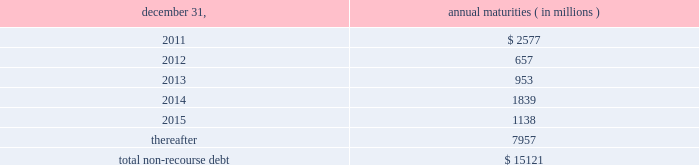The aes corporation notes to consolidated financial statements 2014 ( continued ) december 31 , 2010 , 2009 , and 2008 ( 3 ) multilateral loans include loans funded and guaranteed by bilaterals , multilaterals , development banks and other similar institutions .
( 4 ) non-recourse debt of $ 708 million as of december 31 , 2009 was excluded from non-recourse debt and included in current and long-term liabilities of held for sale and discontinued businesses in the accompanying consolidated balance sheets .
Non-recourse debt as of december 31 , 2010 is scheduled to reach maturity as set forth in the table below : december 31 , annual maturities ( in millions ) .
As of december 31 , 2010 , aes subsidiaries with facilities under construction had a total of approximately $ 432 million of committed but unused credit facilities available to fund construction and other related costs .
Excluding these facilities under construction , aes subsidiaries had approximately $ 893 million in a number of available but unused committed revolving credit lines to support their working capital , debt service reserves and other business needs .
These credit lines can be used in one or more of the following ways : solely for borrowings ; solely for letters of credit ; or a combination of these uses .
The weighted average interest rate on borrowings from these facilities was 3.24% ( 3.24 % ) at december 31 , 2010 .
Non-recourse debt covenants , restrictions and defaults the terms of the company 2019s non-recourse debt include certain financial and non-financial covenants .
These covenants are limited to subsidiary activity and vary among the subsidiaries .
These covenants may include but are not limited to maintenance of certain reserves , minimum levels of working capital and limitations on incurring additional indebtedness .
Compliance with certain covenants may not be objectively determinable .
As of december 31 , 2010 and 2009 , approximately $ 803 million and $ 653 million , respectively , of restricted cash was maintained in accordance with certain covenants of the non-recourse debt agreements , and these amounts were included within 201crestricted cash 201d and 201cdebt service reserves and other deposits 201d in the accompanying consolidated balance sheets .
Various lender and governmental provisions restrict the ability of certain of the company 2019s subsidiaries to transfer their net assets to the parent company .
Such restricted net assets of subsidiaries amounted to approximately $ 5.4 billion at december 31 , 2010. .
What percentage of total non-recourse debt as of december 31 , 2010 is due in 2012? 
Computations: (657 / 15121)
Answer: 0.04345. 